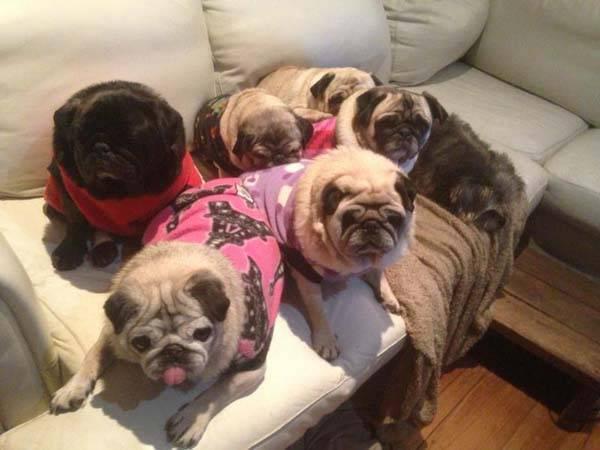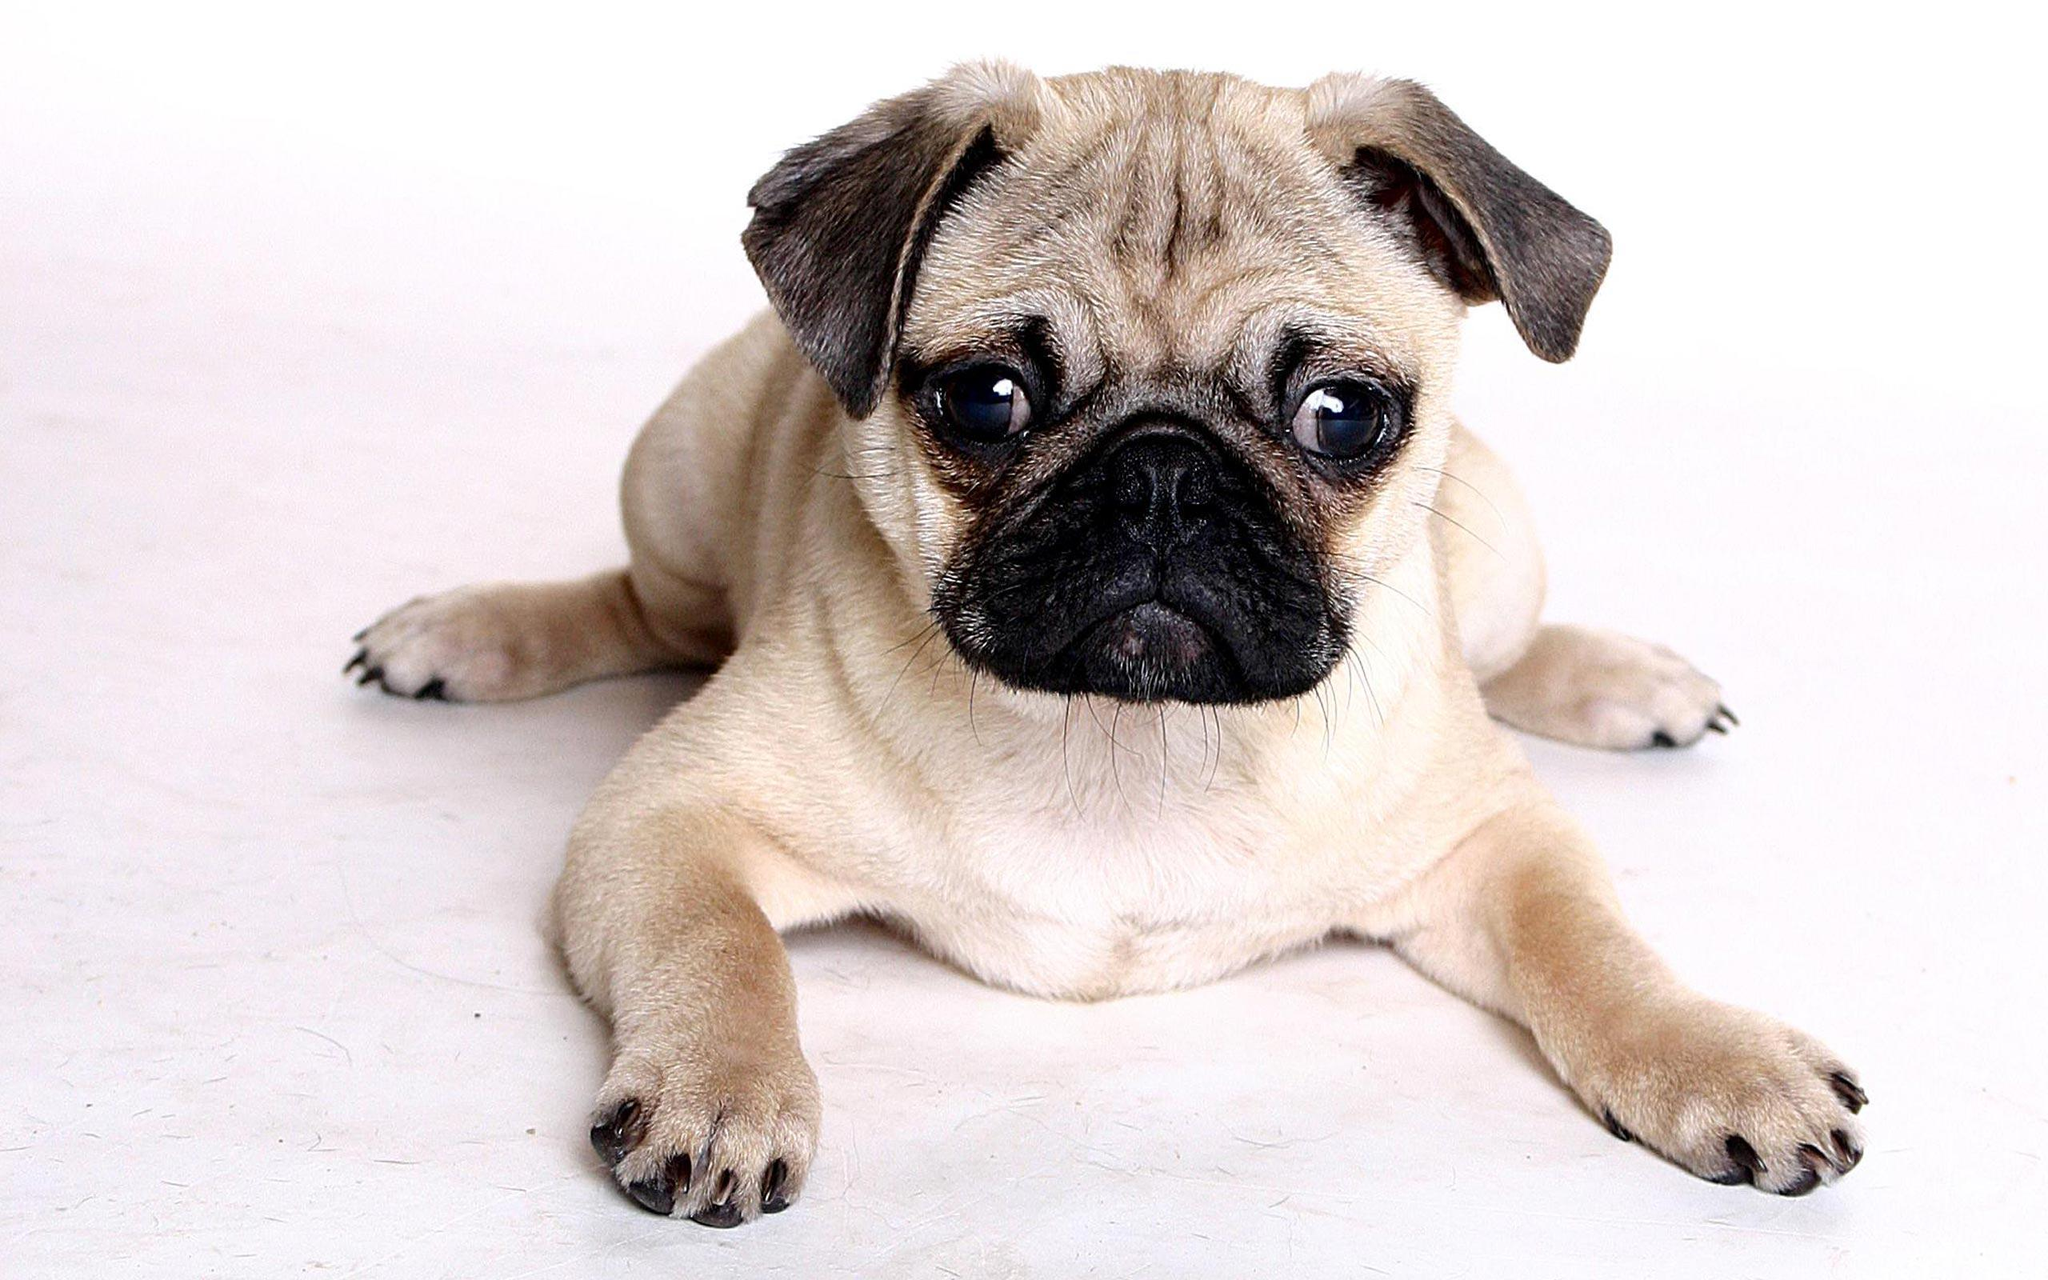The first image is the image on the left, the second image is the image on the right. For the images displayed, is the sentence "There are more pug dogs in the left image than in the right." factually correct? Answer yes or no. Yes. 